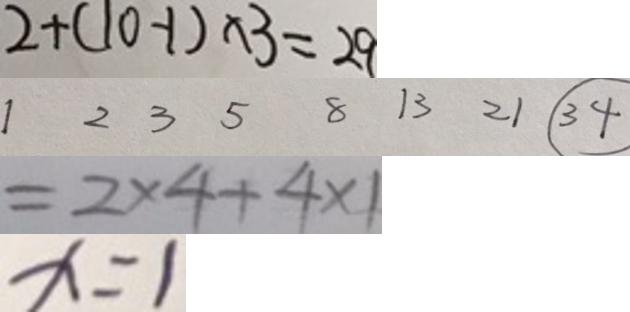<formula> <loc_0><loc_0><loc_500><loc_500>2 + ( 1 0 - 1 ) \times 3 = 2 9 
 1 2 3 5 8 1 3 2 1 \textcircled { 3 4 } 
 = 2 \times 4 + 4 \times 1 
 x = 1</formula> 